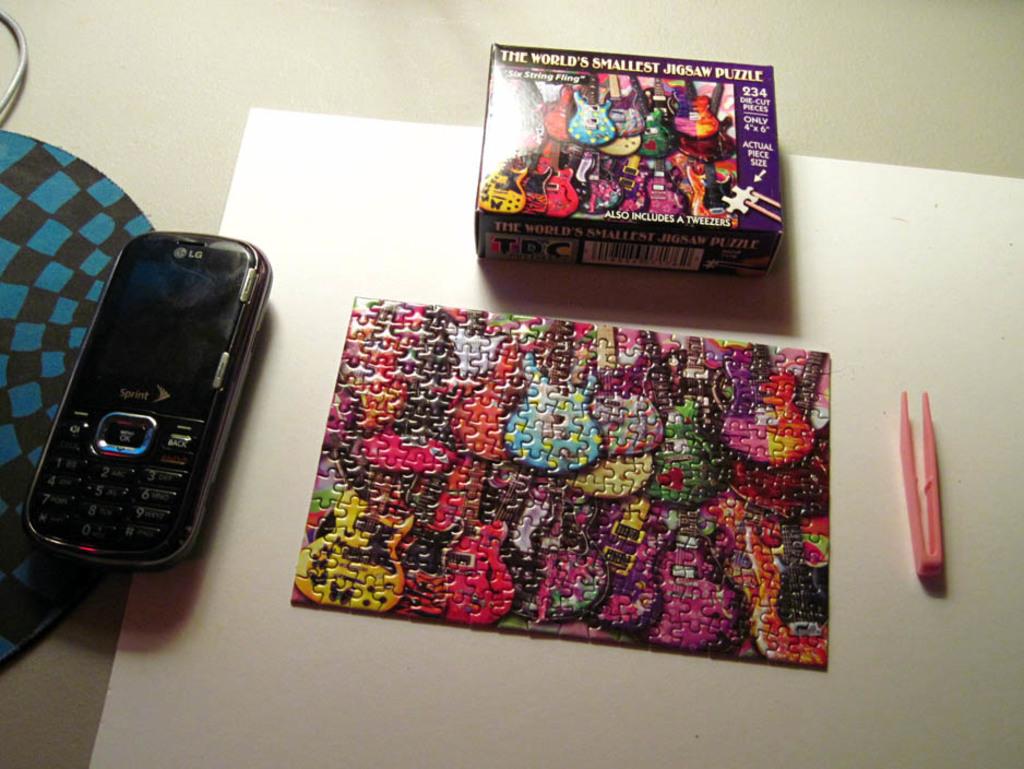Is this the world's smallest or biggest jigsaw puzzle?
Ensure brevity in your answer.  Smallest. What brand is the phone in this picture?
Ensure brevity in your answer.  Lg. 